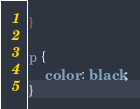Convert code to text. <code><loc_0><loc_0><loc_500><loc_500><_CSS_>}

p {
    color : black;
}
</code> 